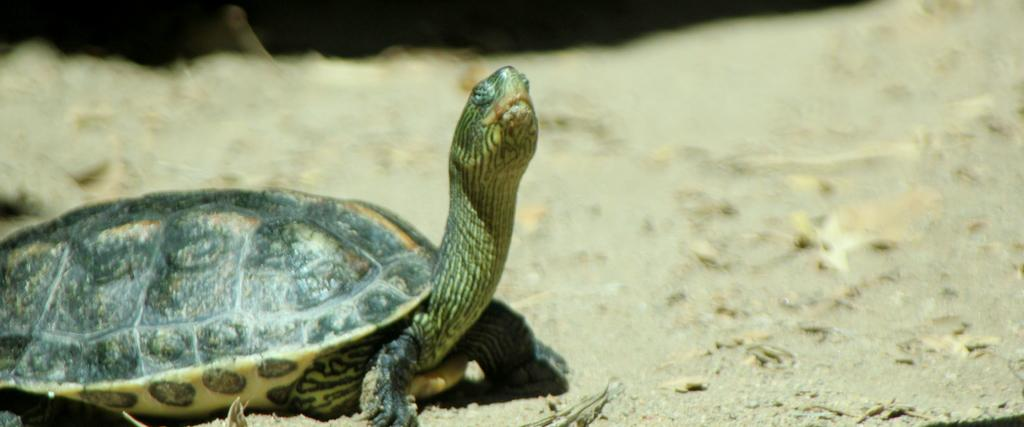What type of animal is in the image? There is a tortoise in the image. What type of journey is the tank taking in the image? There is no tank present in the image; it features a tortoise. What type of team is depicted in the image? There is no team present in the image; it features a tortoise. 